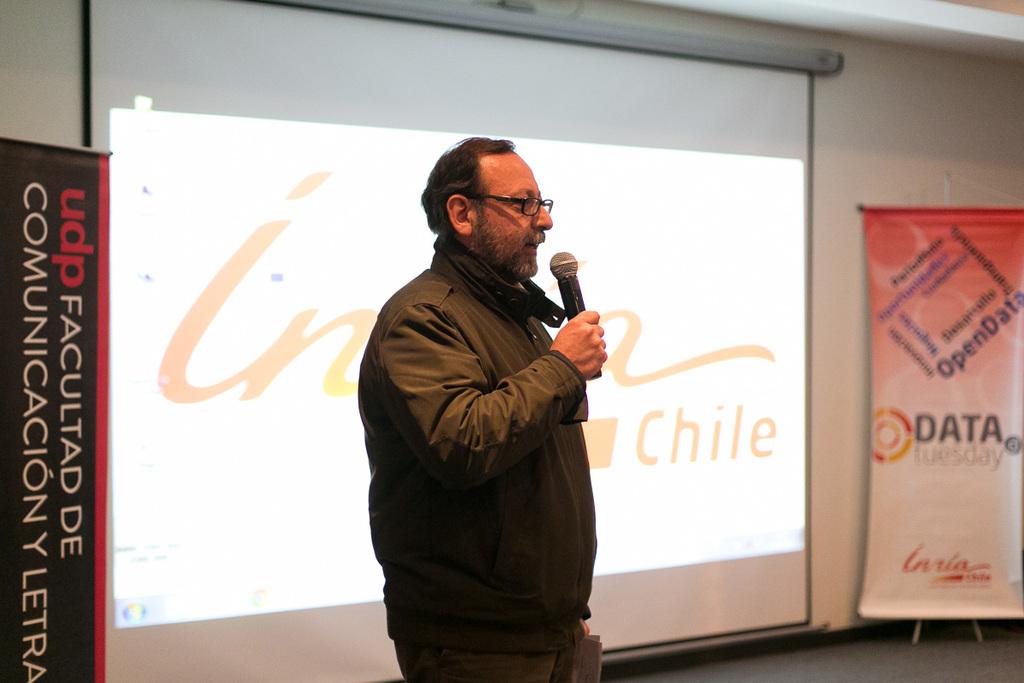Where is the talk being held?
Your answer should be compact. Chile. What day is tuesday?
Offer a very short reply. Data. 